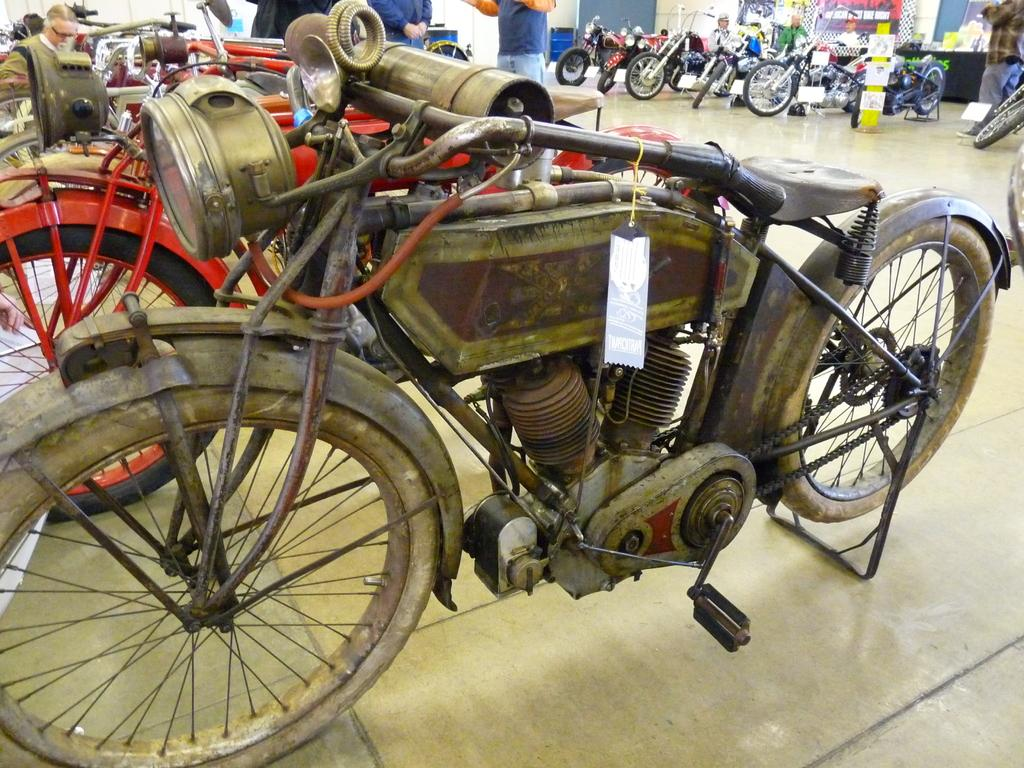What can be seen on the floor in the image? There are different bikes on the floor. What is visible at the top of the image? There are people visible at the top of the image, and there is also a wall. Reasoning: Let's think step by identifying the main subjects and objects in the image based on the provided facts. We then formulate questions that focus on the location and characteristics of these subjects and objects, ensuring that each question can be answered definitively with the information given. We avoid yes/no questions and ensure that the language is simple and clear. Absurd Question/Answer: What type of coal can be seen at the seashore in the image? There is no seashore or coal present in the image. What is the best way to reach the top of the wall in the image? The image does not provide information on how to reach the top of the wall, as it only shows people at the top and a wall. What type of coal can be seen at the seashore in the image? There is no seashore or coal present in the image. What is the best way to reach the top of the wall in the image? The image does not provide information on how to reach the top of the wall, as it only shows people at the top and a wall. 